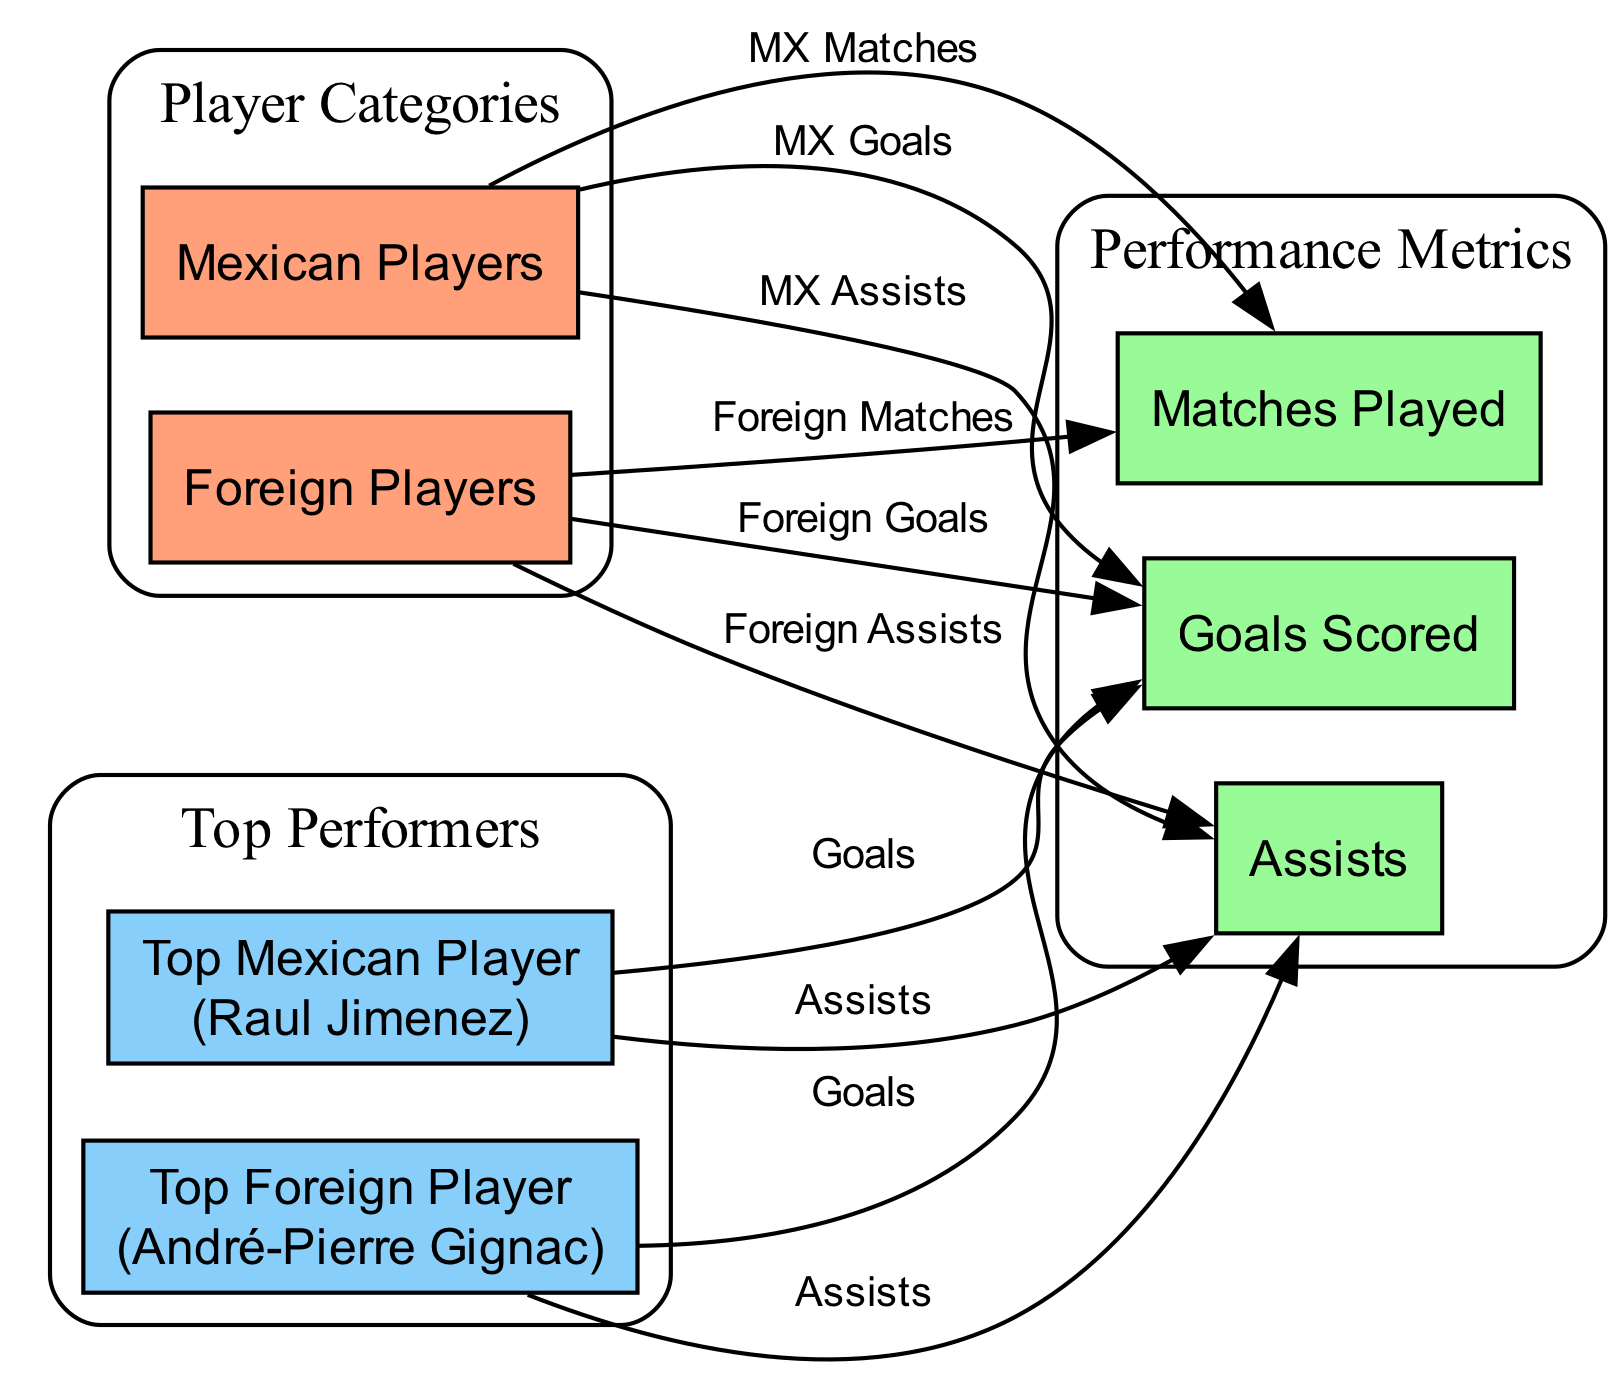What type of players are represented in the diagram? The diagram includes two categories of players: Mexican Players and Foreign Players. These are clearly labeled as separate nodes at the start of the diagram.
Answer: Mexican Players and Foreign Players Who is the top foreign player listed in the diagram? The diagram identifies André-Pierre Gignac as the top foreign player, which is labeled under the appropriate node for top performers.
Answer: André-Pierre Gignac Which category has the most metrics connected to it? Upon examining the diagram, the Mexican Players category has three metrics (Goals Scored, Assists, Matches Played) connected to it, similar to the Foreign Players category; thus both are equally represented.
Answer: Mexican Players and Foreign Players How many edges are connecting to the Goals Scored metric? The Goals Scored metric has edges connecting from both player categories, totaling four edges in total (two from each category: Mexican and Foreign Players).
Answer: 4 What is the relationship between the top Mexican player and his performance metrics? The top Mexican player, Raul Jimenez, is directly connected to the Goals Scored and Assists metrics via edges, indicating that his performance in these areas can be quantified.
Answer: Goals and Assists Which player category has more total matches played? By evaluating the connections in the diagram, while specific numbers of matches are not provided, both categories (Mexican and Foreign Players) seem to have a comparable number of matches played based on the edges connected. However, the overall perception often indicates that foreign players may play more matches historically.
Answer: Comparable (yet traditionally foreign players are perceived to play more) What type of diagram is used here to analyze performance? The diagram used is a scatter plot analysis, represented in a categorized graph format that connects different player categories and their performance metrics, making it easier to compare and contrast.
Answer: Scatter plot analysis What does the connection from foreign players to assists suggest? The connection demonstrates the number of assists made by foreign players, indicating their contribution to team play in the league, as marked by the edge linking them to the assists metric.
Answer: Contribution to team play How are performance metrics labeled for players in the diagram? The performance metrics are labeled clearly, linking players to their achievements via graphical edges labeled as Goals, Assists, and Matches.
Answer: Goals, Assists, Matches 